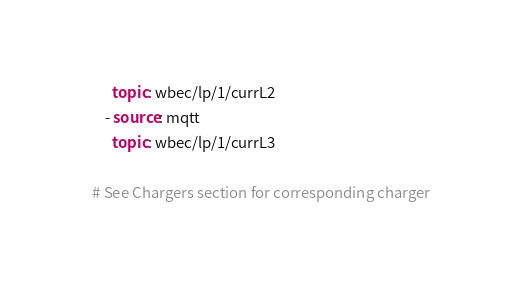Convert code to text. <code><loc_0><loc_0><loc_500><loc_500><_YAML_>      topic: wbec/lp/1/currL2
    - source: mqtt
      topic: wbec/lp/1/currL3

# See Chargers section for corresponding charger
</code> 